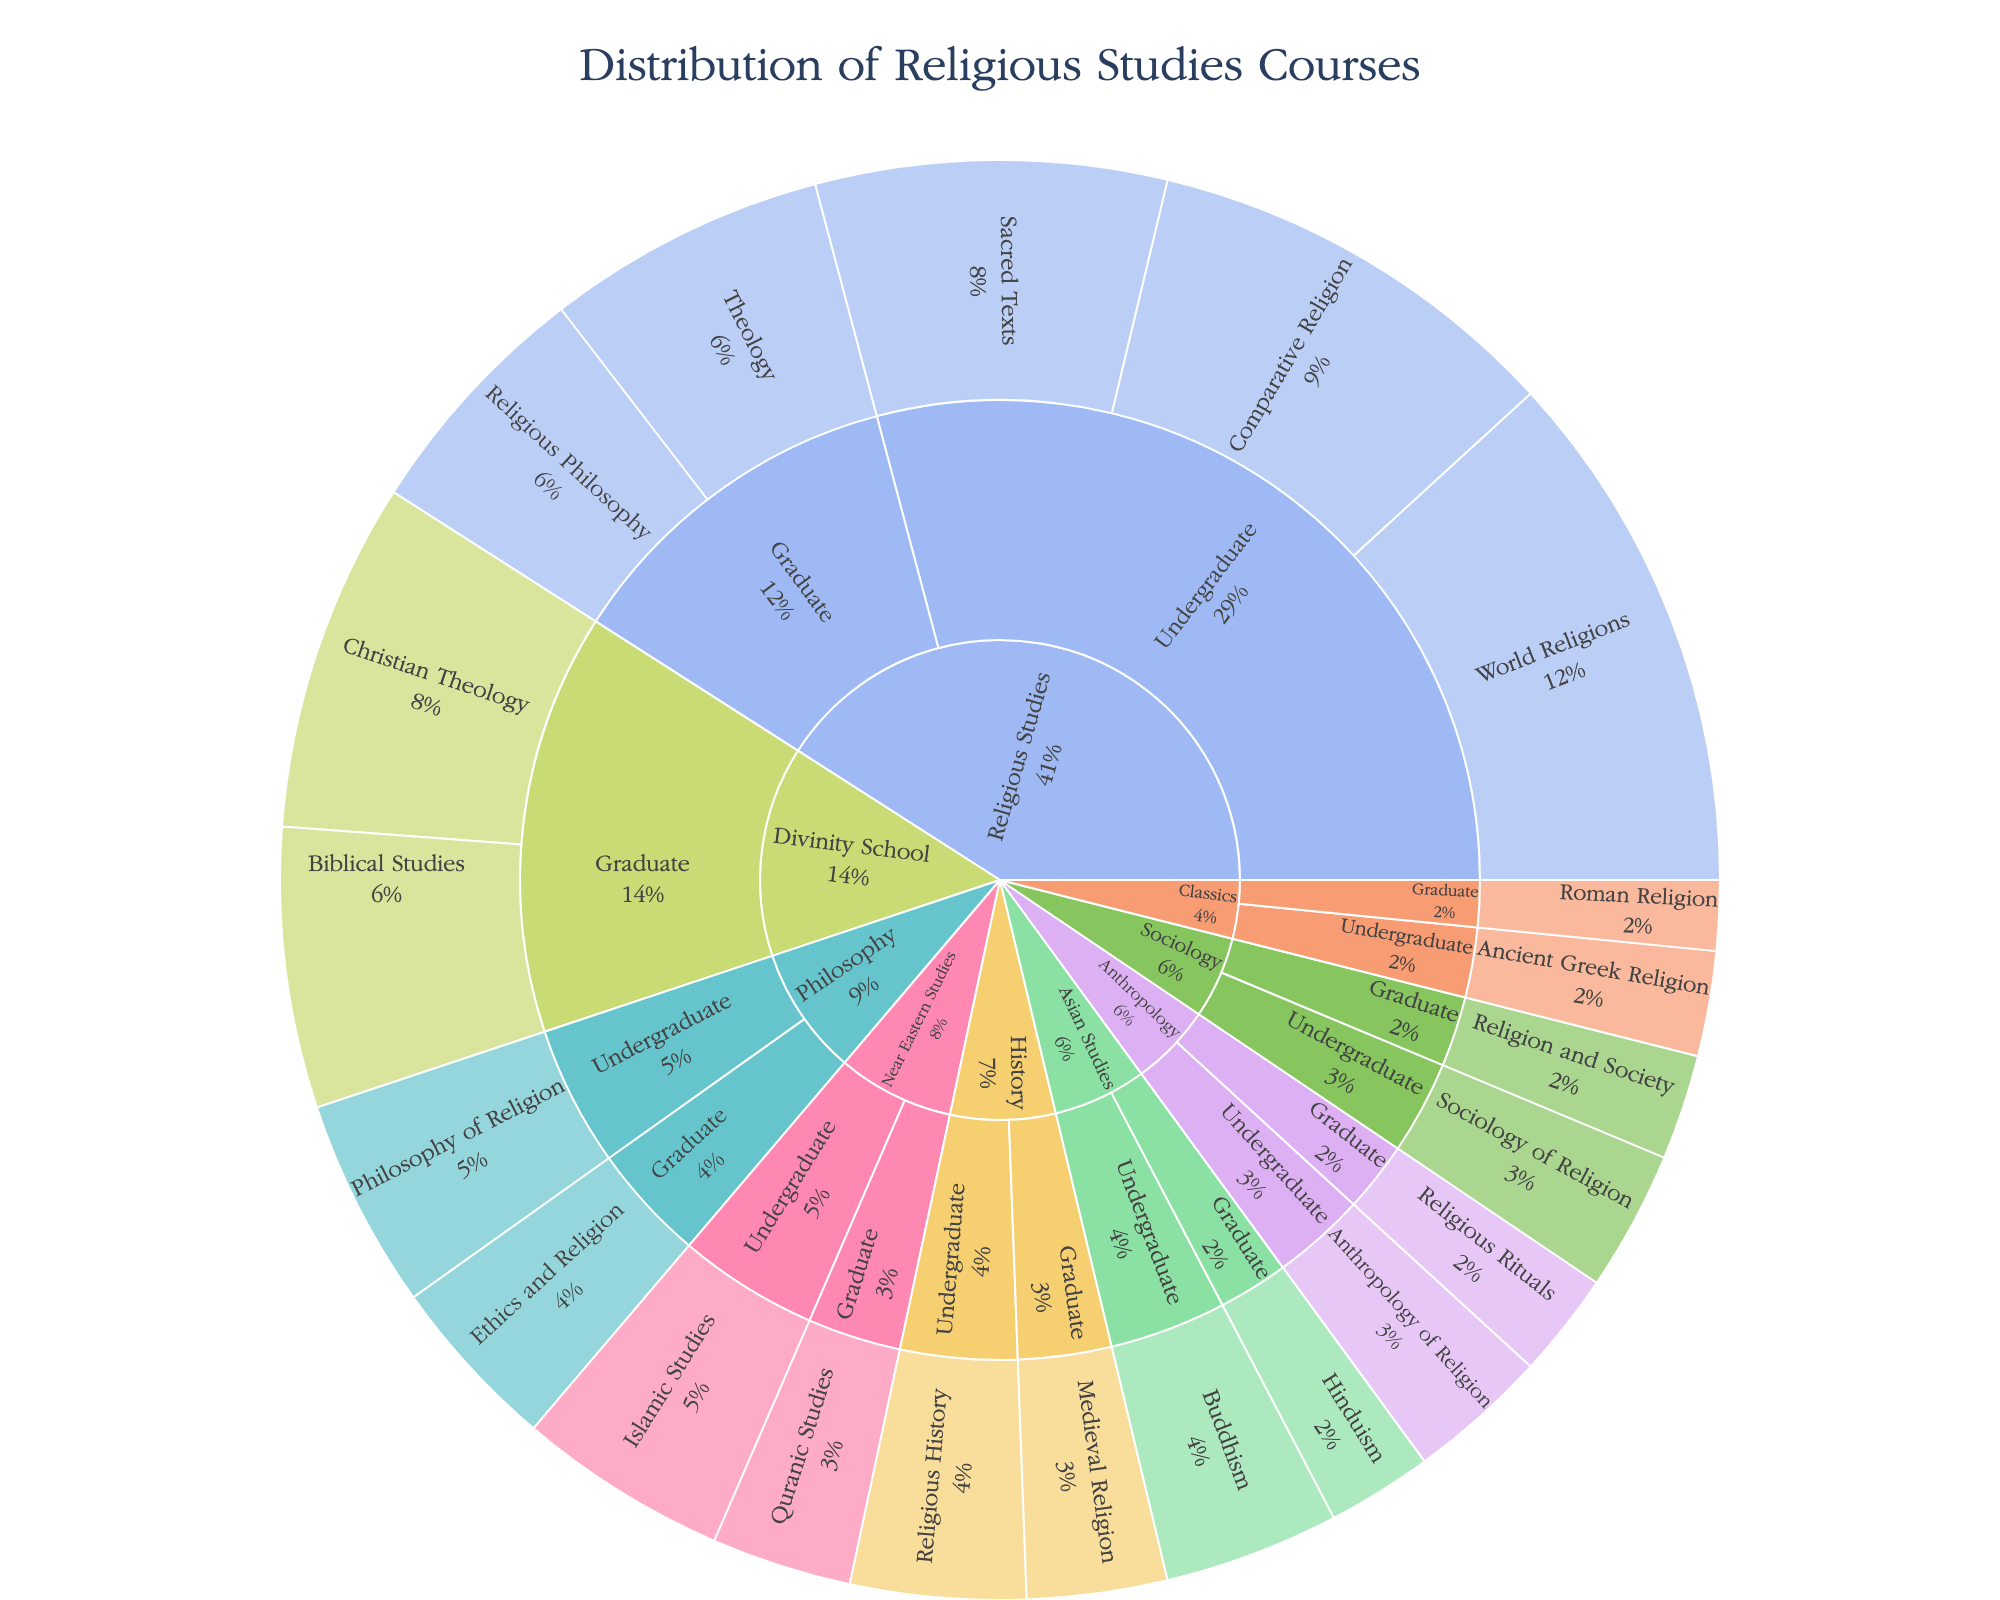What is the title of the figure? The title can be found at the top of the figure, usually in a larger and bold font. It succinctly describes what the figure is about.
Answer: Distribution of Religious Studies Courses Which department has the most undergraduate courses focused on World Religions? By looking at the segments labeled ‘Undergraduate’ under each department and identifying the one with the largest slice for 'World Religions', you can find the department with the most such courses.
Answer: Religious Studies How many graduate courses are there in total across all departments? Sum the course counts for all segments labeled 'Graduate' in various departments: (8+7+5+3+4+3+2+10+8). The total number of graduate courses is the sum of these values.
Answer: 50 Which has more courses: Undergraduate Sacred Texts or Graduate Biblical Studies? Compare the number of courses for the segments 'Sacred Texts' under 'Undergraduate' and 'Biblical Studies' under 'Graduate'. Identify which segment has a higher count.
Answer: Graduate Biblical Studies What is the specific focus with the least number of courses in any graduate department? Inspect all segments labeled 'Graduate' and their sub-segments for the smallest value.
Answer: Roman Religion Which department offers the highest number of graduate courses in total? Sum the courses for each 'Graduate' department: 
Religious Studies (8+7), 
Philosophy (5), 
Sociology (3), 
Anthropology (3), 
History (4), 
Near Eastern Studies (4), 
Asian Studies (3), 
Classics (2),
Divinity School (10+8). 
The department with the highest sum is identified.
Answer: Divinity School How many undergraduate courses are offered in Near Eastern Studies focusing on Islamic Studies? Locate the segment 'Undergraduate' under the department 'Near Eastern Studies' and see the value for 'Islamic Studies'.
Answer: 6 Which has a larger percentage of total courses: Undergraduate Sociology of Religion or Undergraduate Anthropology of Religion? By comparing the segment sizes of 'Sociology of Religion' under 'Undergraduate' and 'Anthropology of Religion' under 'Undergraduate', determine which occupies a larger relative portion of the entire chart.
Answer: Undergraduate Sociology of Religion How many total courses are offered in departments outside of Religious Studies? Sum the courses for all segments in departments other than 'Religious Studies': 
6+5+4+3+4+3+5+4+6+4+5+3+3+2. The total number gives the sum.
Answer: 57 